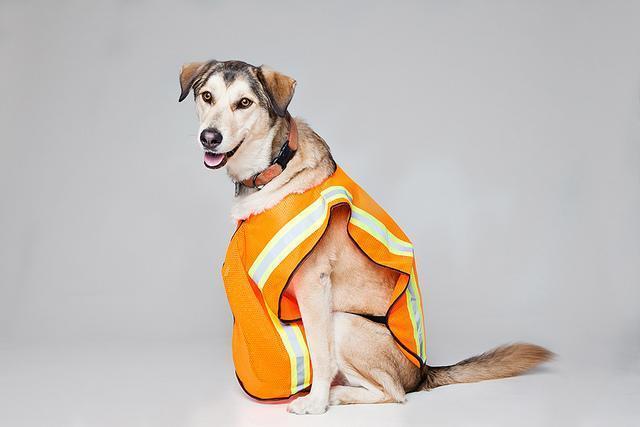How many animals are in the image?
Give a very brief answer. 1. 